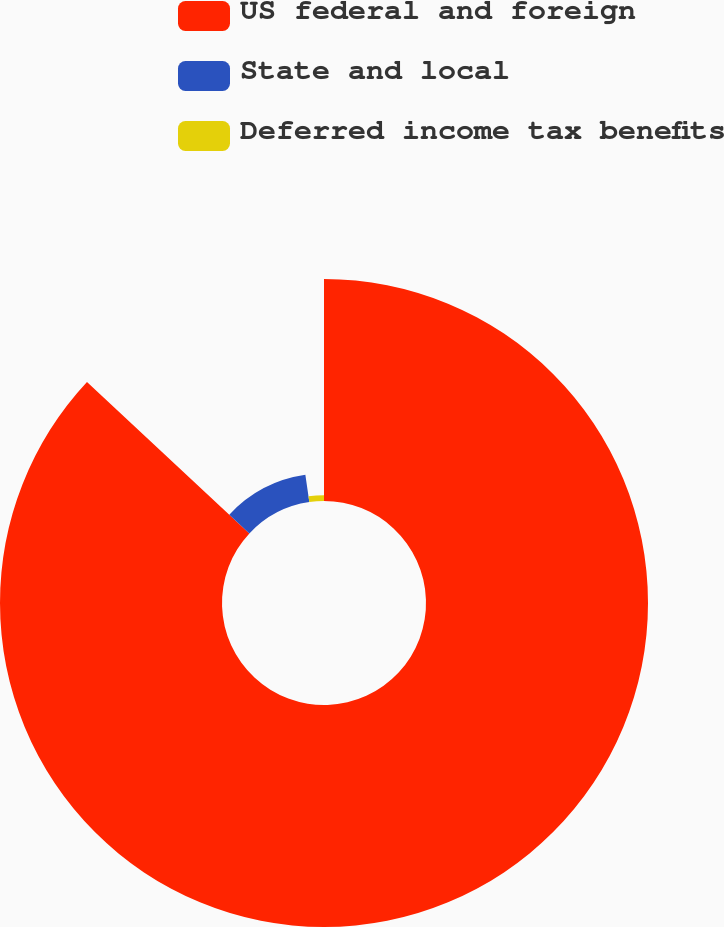Convert chart to OTSL. <chart><loc_0><loc_0><loc_500><loc_500><pie_chart><fcel>US federal and foreign<fcel>State and local<fcel>Deferred income tax benefits<nl><fcel>86.94%<fcel>10.76%<fcel>2.3%<nl></chart> 